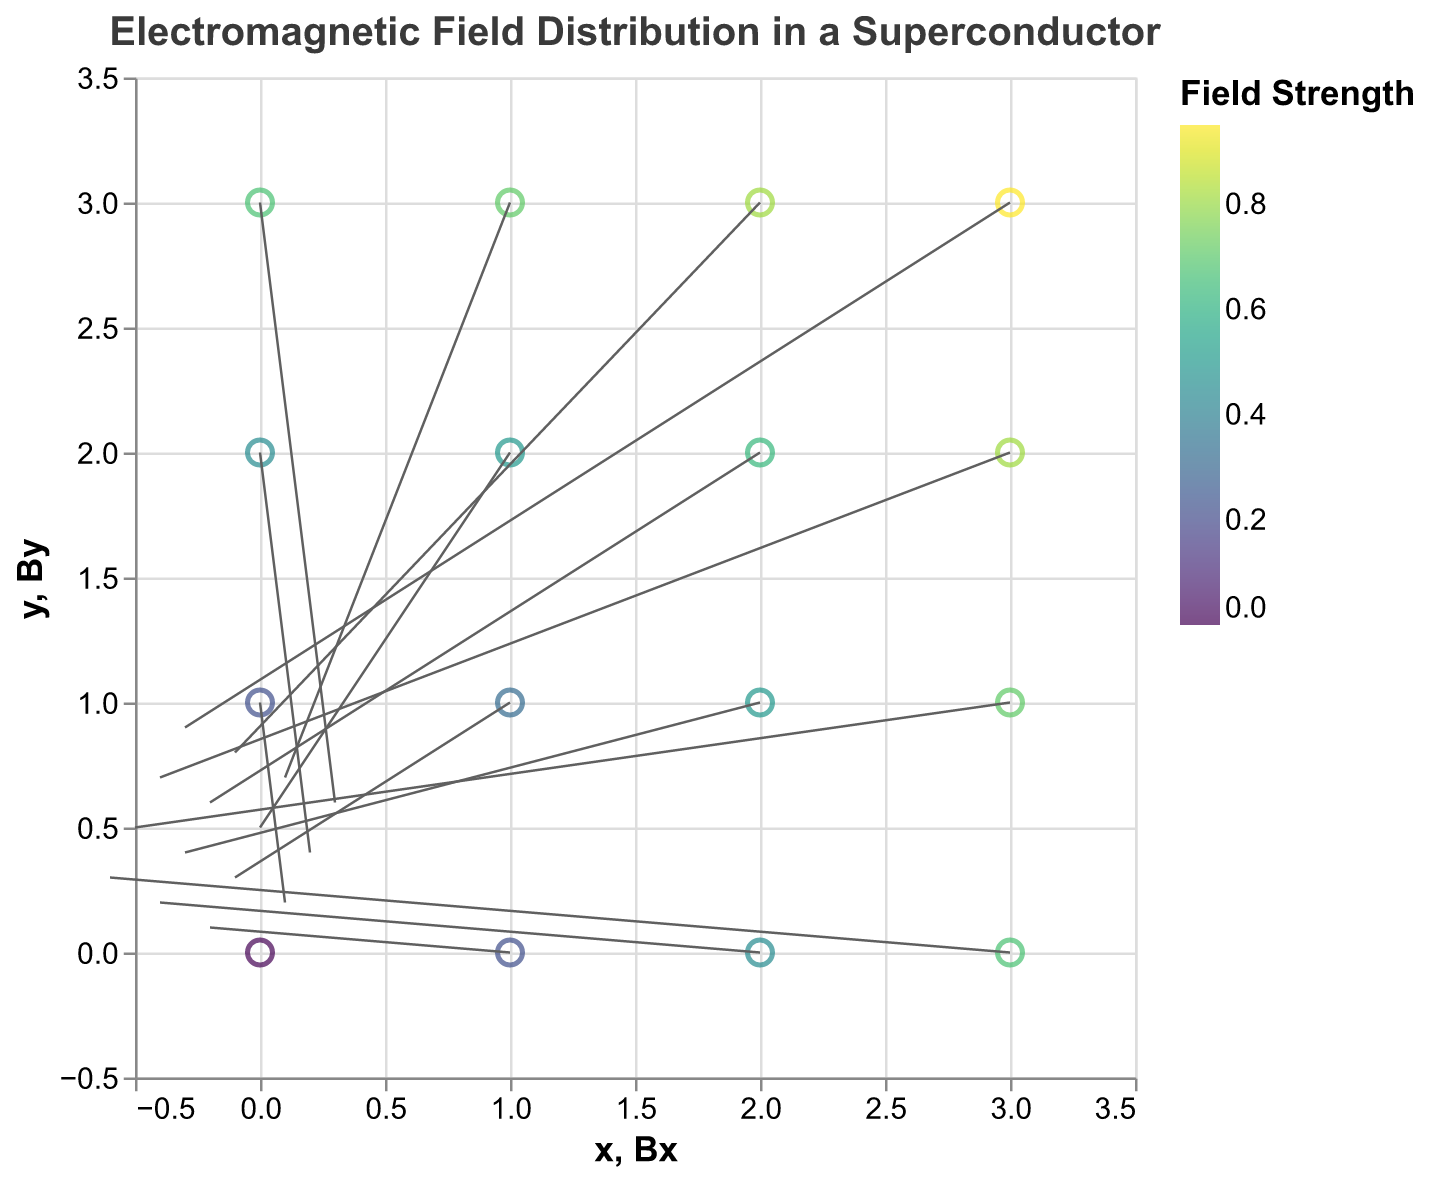What is the title of this plot? The title is mentioned at the top of the plot, which provides an idea about what this plot represents. The title here is "Electromagnetic Field Distribution in a Superconductor".
Answer: Electromagnetic Field Distribution in a Superconductor How many data points are plotted in this figure? Each coordinate (x, y) pair represents one data point, and there are 16 (4x4 grid) unique pairs visible in the plot.
Answer: 16 Which axis represents the horizontal position? The axis representing the horizontal position is labeled with the variable "x" in the plot.
Answer: x-axis Where is the point with the highest field strength located? To find the highest field strength, look for the data point with the darkest color, based on the 'viridis' color scheme. The strongest field is at (3, 3).
Answer: (3, 3) What is the field strength at the point (0, 0)? Find the point (0, 0) and read its field strength from the color legend. It is 0.
Answer: 0 Which direction does the arrow at the point (1, 2) point to? The arrow at (1, 2) points in the direction given by components (Bx, By). Here, Bx=0 and By=0.5, indicating an upward direction.
Answer: Upward Is the field strength higher at (2, 2) or (1, 1)? Compare the field strength at both points; (2, 2) has a strength of 0.63 and (1, 1) has a strength of 0.32. Hence, (2, 2) has a higher field strength.
Answer: (2, 2) Which field vector has the longest length? The longest vector corresponds to the highest field strength. Check the 'Field Strength' values and the corresponding vectors; the highest field strength is 0.95 at (3, 3).
Answer: (3, 3) What is the average field strength of all the data points? To find the average, sum all the field strength values and divide by the number of data points: (0 + 0.22 + 0.45 + 0.67 + 0.22 + 0.32 + 0.50 + 0.71 + 0.45 + 0.50 + 0.63 + 0.81 + 0.67 + 0.71 + 0.81 + 0.95) / 16 = 7.62 / 16 ≈ 0.48
Answer: 0.48 What does the color represent in this plot? The color represents the field strength, as indicated by the color legend which ranges from light to dark shades of the 'viridis' color scheme.
Answer: Field Strength 